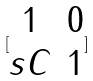<formula> <loc_0><loc_0><loc_500><loc_500>[ \begin{matrix} 1 & 0 \\ s C & 1 \end{matrix} ]</formula> 